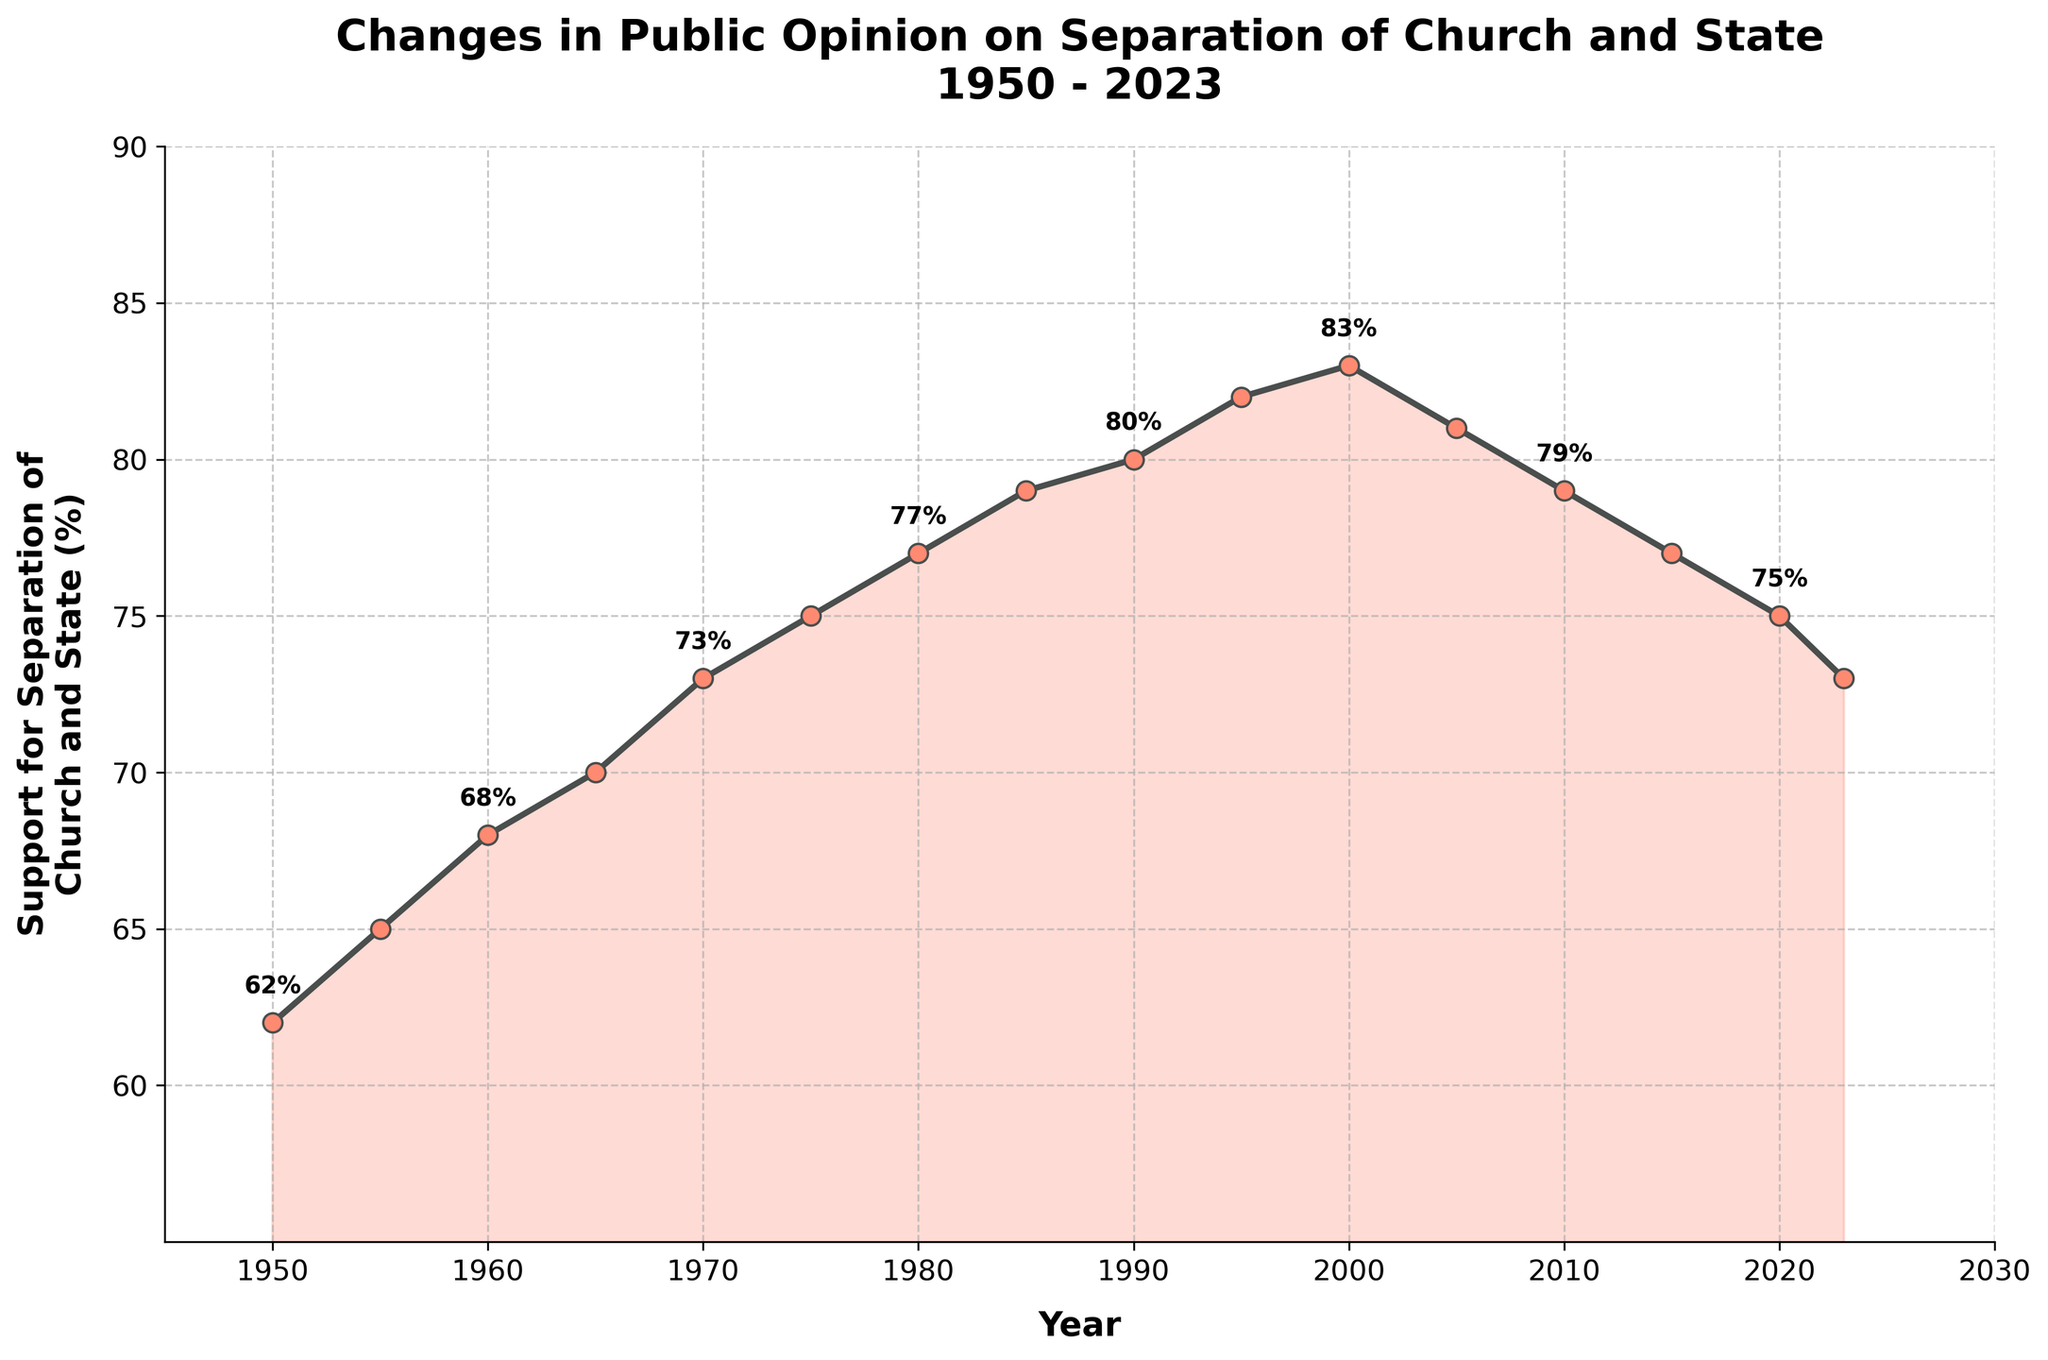What trend can be observed in the support for separation of church and state from 1950 to 1990? The figure shows an overall upward trend from 62% in 1950 to 80% in 1990, indicating increasing public support over these four decades.
Answer: Upward trend What is the highest recorded support for the separation of church and state and in what year did it occur? The highest value on the y-axis labeled "Support for Separation of Church and State (%)" is 83%, and it occurred in the year 2000 as observed from the figure.
Answer: 83% in 2000 How does the support in 2020 compare to the support in 2010? According to the figure, the support for separation stood at 75% in 2020 compared to 79% in 2010. Therefore, support decreased by 4 percentage points.
Answer: Decreased by 4 percentage points What is the average support for separation of church and state from 1950 to 2023? To calculate the average, add all support values and divide by the number of data points: (62 + 65 + 68 + 70 + 73 + 75 + 77 + 79 + 80 + 82 + 83 + 81 + 79 + 77 + 75 + 73) / 16 = 75.5%.
Answer: 75.5% Describe the trend in support for separation of church and state from 2000 to present. From 2000 (83%) to 2023 (73%), the figure shows a clear downward trend, with support gradually decreasing overall.
Answer: Downward trend Which decade saw the largest increase in support for the separation of church and state, and what was the increase in percentage points? The 1950s (1950: 62%, 1960: 68%) saw an increase of 6 points. The 1960s (1960: 68%, 1970: 73%) saw an increase of 5 points. The 1970s (1970: 73%, 1980: 77%) saw an increase of 4 points. Since the largest increase was in the 1950s, the increase is 6 points.
Answer: 1950s, 6 percentage points What are the two lowest recorded percentages of support, and in what years did they occur after the year 2000? After the year 2000, the two lowest percentages are 73% in 2023 and 75% in 2020, as shown by the data points in the figure.
Answer: 73% in 2023 and 75% in 2020 How many years did support for separation of church and state appear to be at least 80%? Reviewing the figure, from 1990 (80%) to 2005 (81% and 83%), the support was at least 80%. This period covers 1990, 1995, 2000, 2005, which totals 4 measurements/years.
Answer: 4 years What pattern can be observed in the labeling of the support data points on the figure? The labels with percentage values are applied to every other data point: 1950 (62%), 1960 (68%), 1970 (73%), 1980 (77%), 1990 (80%), 2000 (83%), 2010 (79%), 2020 (75%).
Answer: Every other point labeled 